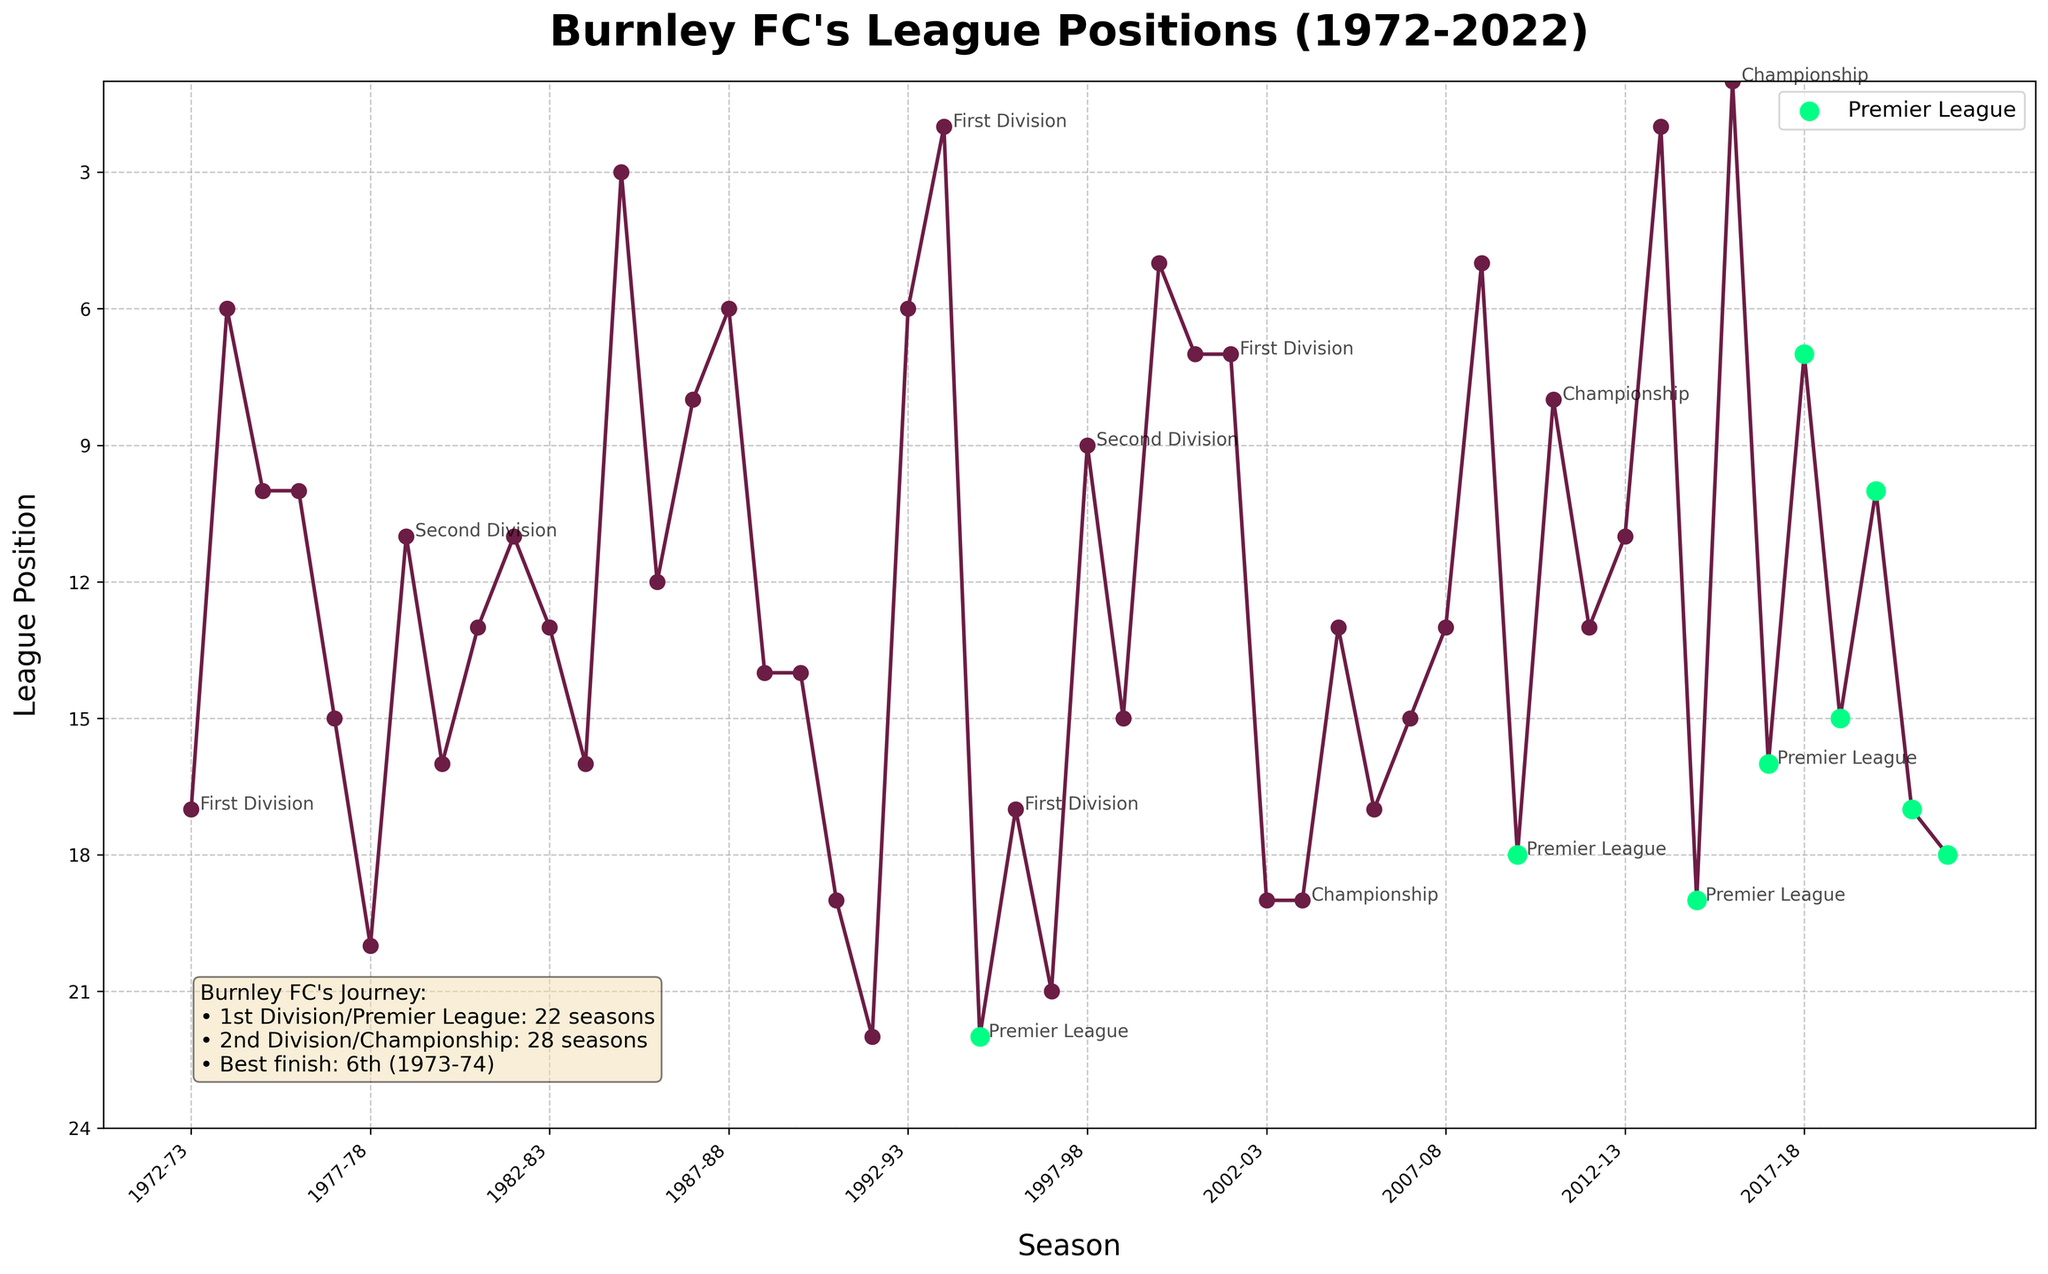Which season had Burnley's best league position? To find Burnley's best league position, look for the lowest value on the y-axis (since lower positions are better) and note the corresponding season. The lowest point is at position 6 in the 1973-74 season.
Answer: 1973-74 How many times did Burnley finish in the top 10 of the Premier League? Count the points highlighted in green that are at positions 1 through 10 on the y-axis. The green dots represent Premier League seasons. Burnley finished in the top 10 in the 2009-10 (7th) and 2017-18 (7th) seasons.
Answer: 2 Which league did Burnley predominantly compete in over the 50 seasons? Observe the annotations on the figure indicating league information. There are more annotations for the Championship and Second Division compared to the Premier League and First Division.
Answer: Championship/Second Division Between which two seasons was Burnley's worst league position? Locate the highest value on the y-axis for the entire plot, which indicates the worst league position. The highest point is at position 22 in the 1985-86 and 1994-95 seasons.
Answer: 1985-86 and 1994-95 Did Burnley spend more seasons in the Premier League or in lower divisions? Count the green dots (Premier League seasons) and compare with the number of seasons in other leagues (mostly Championship/Second Division). There are fewer green dots than other dots.
Answer: Lower divisions How many times did Burnley get relegated from the Premier League? Look for transitions from Premier League positions (green dots) to lower league positions (non-green dots) in subsequent seasons. This occurred 3 times: after the 1994-95, 2009-10, and 2014-15 seasons.
Answer: 3 Which season saw Burnley achieving the highest position in a different league after being relegated from the Premier League? Identify seasons following a Premier League relegation (1994-95, 2009-10, and 2014-15) and check the position in those following seasons. Burnley achieved 1st in the Championship in the 2015-16 season.
Answer: 2015-16 What's the difference between Burnley's best finish in the Premier League and their best finish in any other league over the 50 seasons? Burnley's best Premier League finish is 7th (positions in 2009-10 and 2017-18), and their overall best finish is 1st (2015-16 in Championship). The difference between these positions is 6.
Answer: 6 